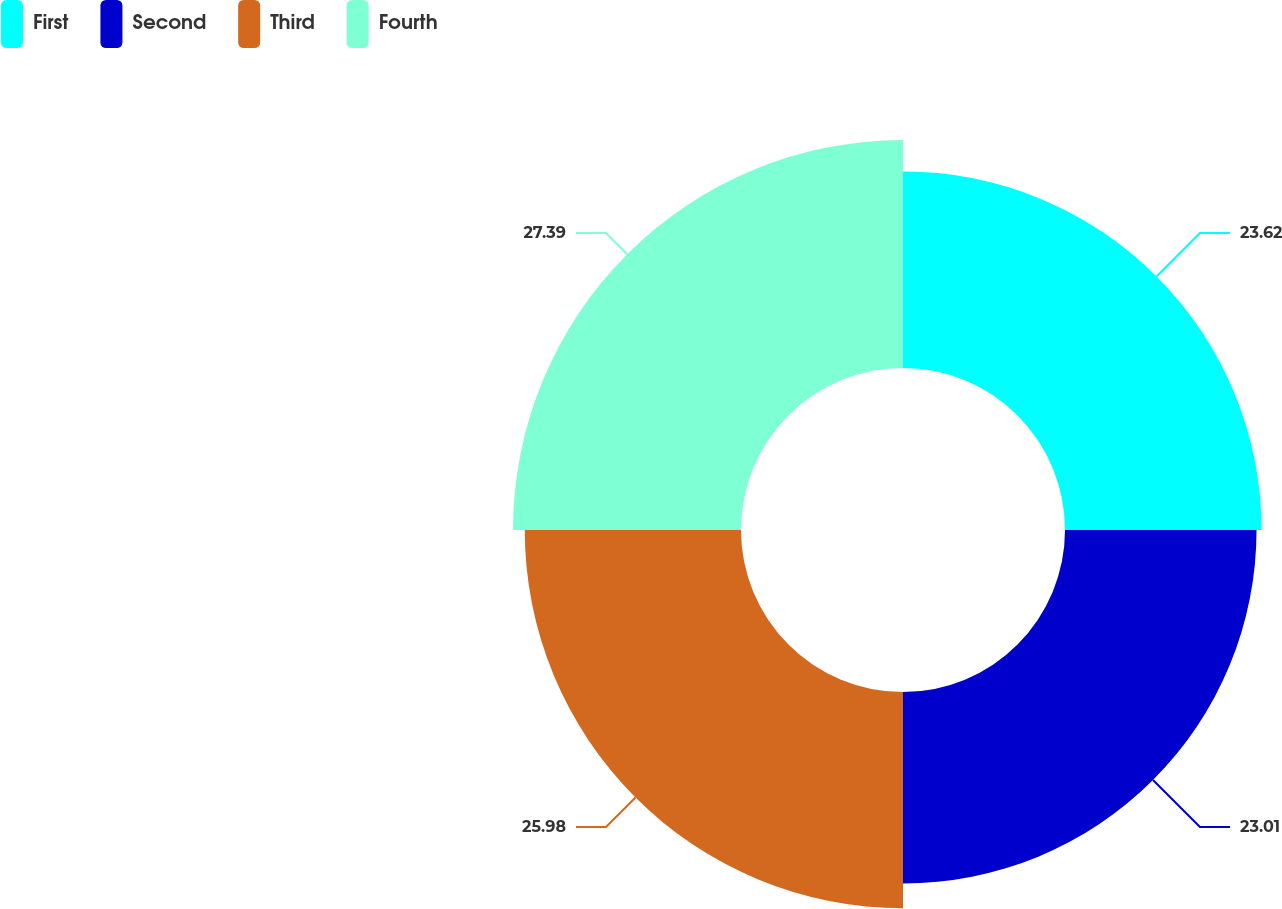Convert chart. <chart><loc_0><loc_0><loc_500><loc_500><pie_chart><fcel>First<fcel>Second<fcel>Third<fcel>Fourth<nl><fcel>23.62%<fcel>23.01%<fcel>25.98%<fcel>27.39%<nl></chart> 